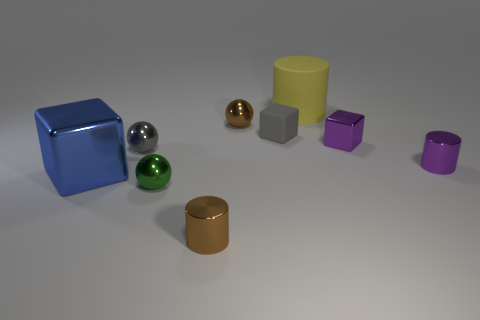What number of metallic things are small gray spheres or yellow objects?
Keep it short and to the point. 1. There is a brown metal thing that is in front of the tiny metallic sphere that is behind the gray shiny sphere; how many balls are in front of it?
Offer a terse response. 0. There is a brown metal object that is in front of the brown ball; is its size the same as the gray thing on the right side of the brown cylinder?
Give a very brief answer. Yes. There is a gray object that is the same shape as the blue shiny thing; what material is it?
Offer a very short reply. Rubber. How many large things are either brown things or purple metal cubes?
Provide a succinct answer. 0. What is the material of the blue block?
Offer a very short reply. Metal. There is a block that is right of the large blue metal thing and left of the big cylinder; what material is it made of?
Offer a terse response. Rubber. Is the color of the small matte thing the same as the ball that is left of the tiny green object?
Keep it short and to the point. Yes. There is a gray cube that is the same size as the brown cylinder; what is it made of?
Ensure brevity in your answer.  Rubber. Are there any gray objects made of the same material as the large yellow thing?
Ensure brevity in your answer.  Yes. 